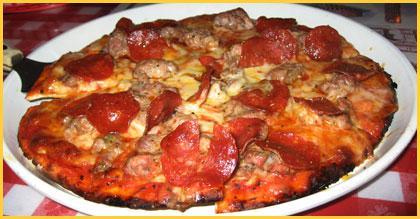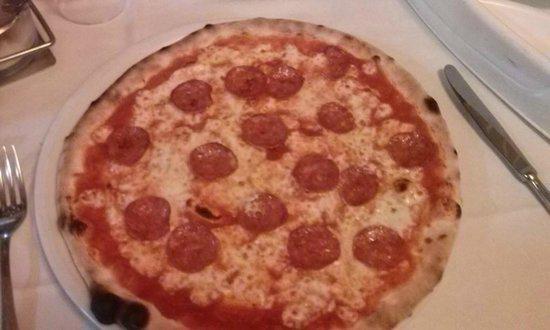The first image is the image on the left, the second image is the image on the right. Examine the images to the left and right. Is the description "The pizza in the image on the left is sitting on a red checked table cloth." accurate? Answer yes or no. Yes. The first image is the image on the left, the second image is the image on the right. Considering the images on both sides, is "Two pizzas on white plates are baked and ready to eat, one plate sitting on a red checked tablecloth." valid? Answer yes or no. Yes. 